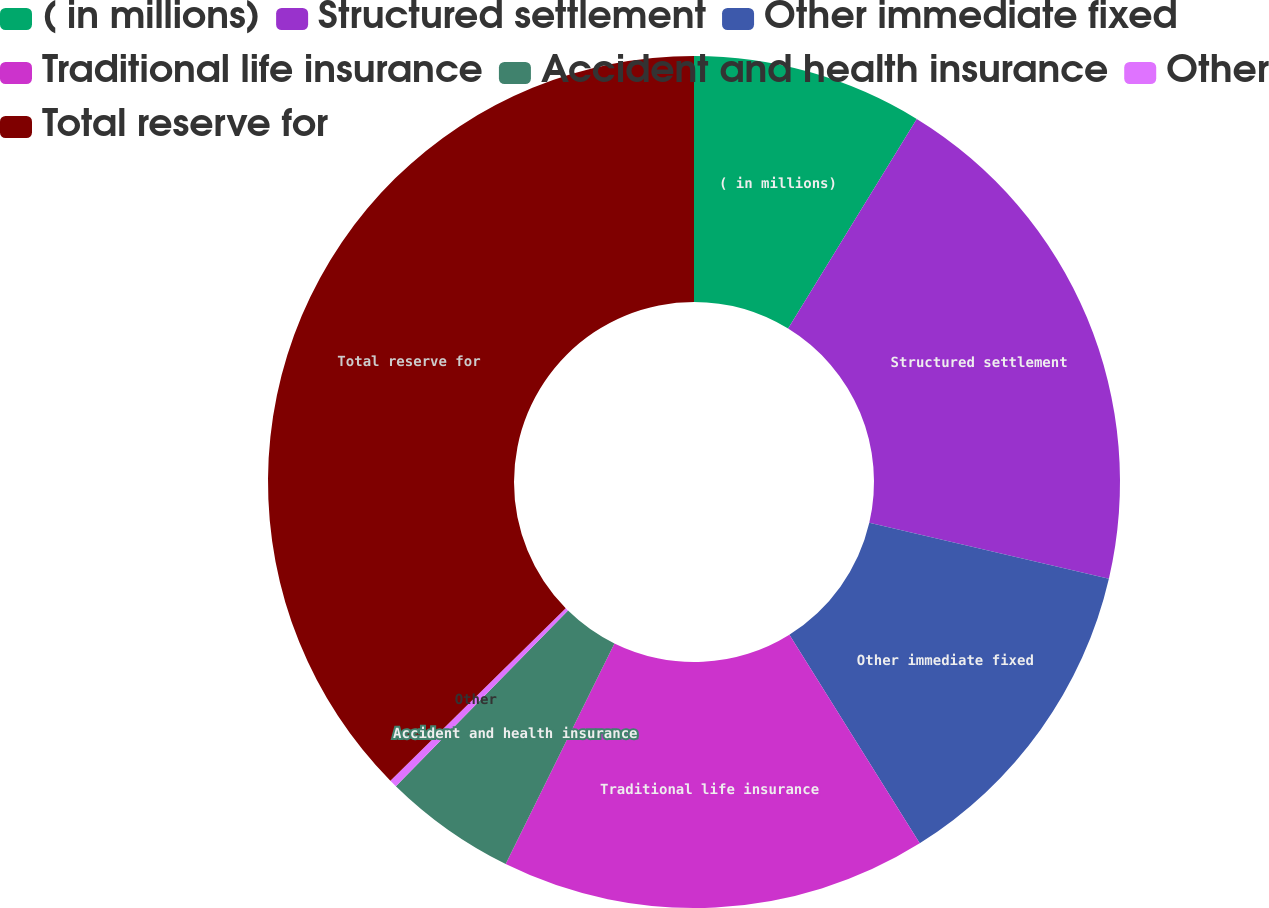Convert chart to OTSL. <chart><loc_0><loc_0><loc_500><loc_500><pie_chart><fcel>( in millions)<fcel>Structured settlement<fcel>Other immediate fixed<fcel>Traditional life insurance<fcel>Accident and health insurance<fcel>Other<fcel>Total reserve for<nl><fcel>8.76%<fcel>19.89%<fcel>12.47%<fcel>16.18%<fcel>5.05%<fcel>0.29%<fcel>37.38%<nl></chart> 